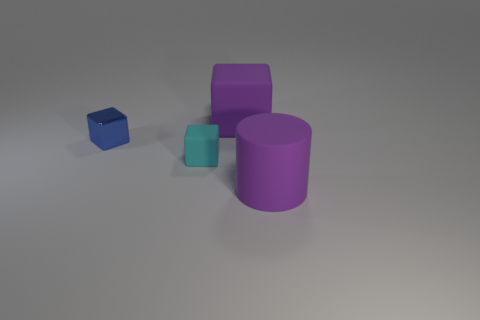Add 1 gray spheres. How many objects exist? 5 Subtract all cylinders. How many objects are left? 3 Add 1 red balls. How many red balls exist? 1 Subtract 0 green cylinders. How many objects are left? 4 Subtract all small purple shiny blocks. Subtract all tiny cyan things. How many objects are left? 3 Add 3 cyan matte cubes. How many cyan matte cubes are left? 4 